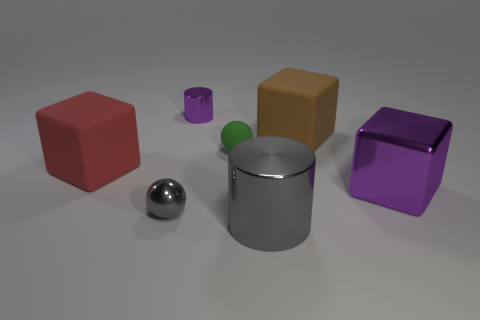Subtract all gray cubes. Subtract all green cylinders. How many cubes are left? 3 Add 1 large brown metal objects. How many objects exist? 8 Subtract all cylinders. How many objects are left? 5 Subtract all small cyan spheres. Subtract all purple metal cylinders. How many objects are left? 6 Add 6 small purple shiny cylinders. How many small purple shiny cylinders are left? 7 Add 1 large red matte blocks. How many large red matte blocks exist? 2 Subtract 1 purple cubes. How many objects are left? 6 